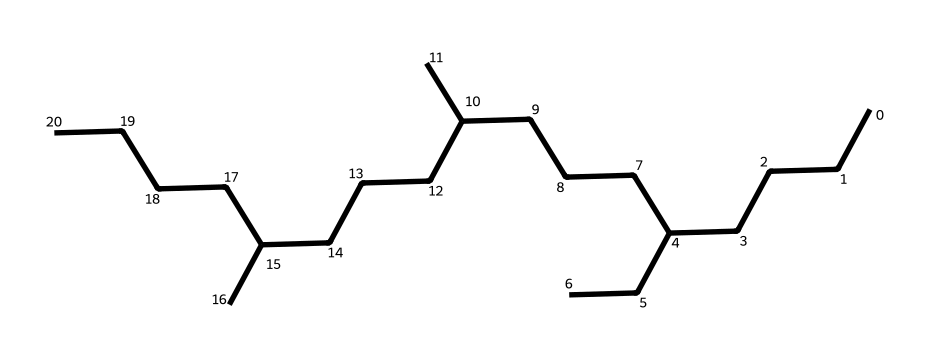What is the total number of carbon atoms in this chemical? To find the total number of carbon atoms, we count the distinct 'C' symbols in the SMILES representation. The given structure contains several groups of carbons, which can be combined to count them: there are 28 carbon atoms in total.
Answer: 28 How many branches does this molecule have? Branching in a chemical structure can usually be identified by looking for carbons that are not part of the longest continuous chain. In this case, the molecule has three branches coming off the main carbon chain.
Answer: 3 Is this chemical saturated or unsaturated? Saturated molecules have all single bonds between carbon atoms, while unsaturated contain double or triple bonds. In this SMILES structure, only single bonds are present, indicating that it is saturated.
Answer: saturated What type of compound is represented by the given SMILES? The structure is consistent with aliphatic hydrocarbons, particularly alkanes, which are characterized by their single bonds and saturated nature. Therefore, this compound is an alkane.
Answer: alkane What is the approximate molecular weight of this chemical? To estimate the molecular weight, we count the number of carbon and hydrogen atoms. Each carbon has an atomic weight of about 12, and each hydrogen about 1. The total can be calculated, yielding an approximate molecular weight of 392 grams per mole.
Answer: 392 What is the main purpose of this chemical in ship engines? Synthetic lubricants are primarily used in ship engines to reduce friction between moving parts, thereby improving efficiency and extending the life of the engine components.
Answer: reduce friction 